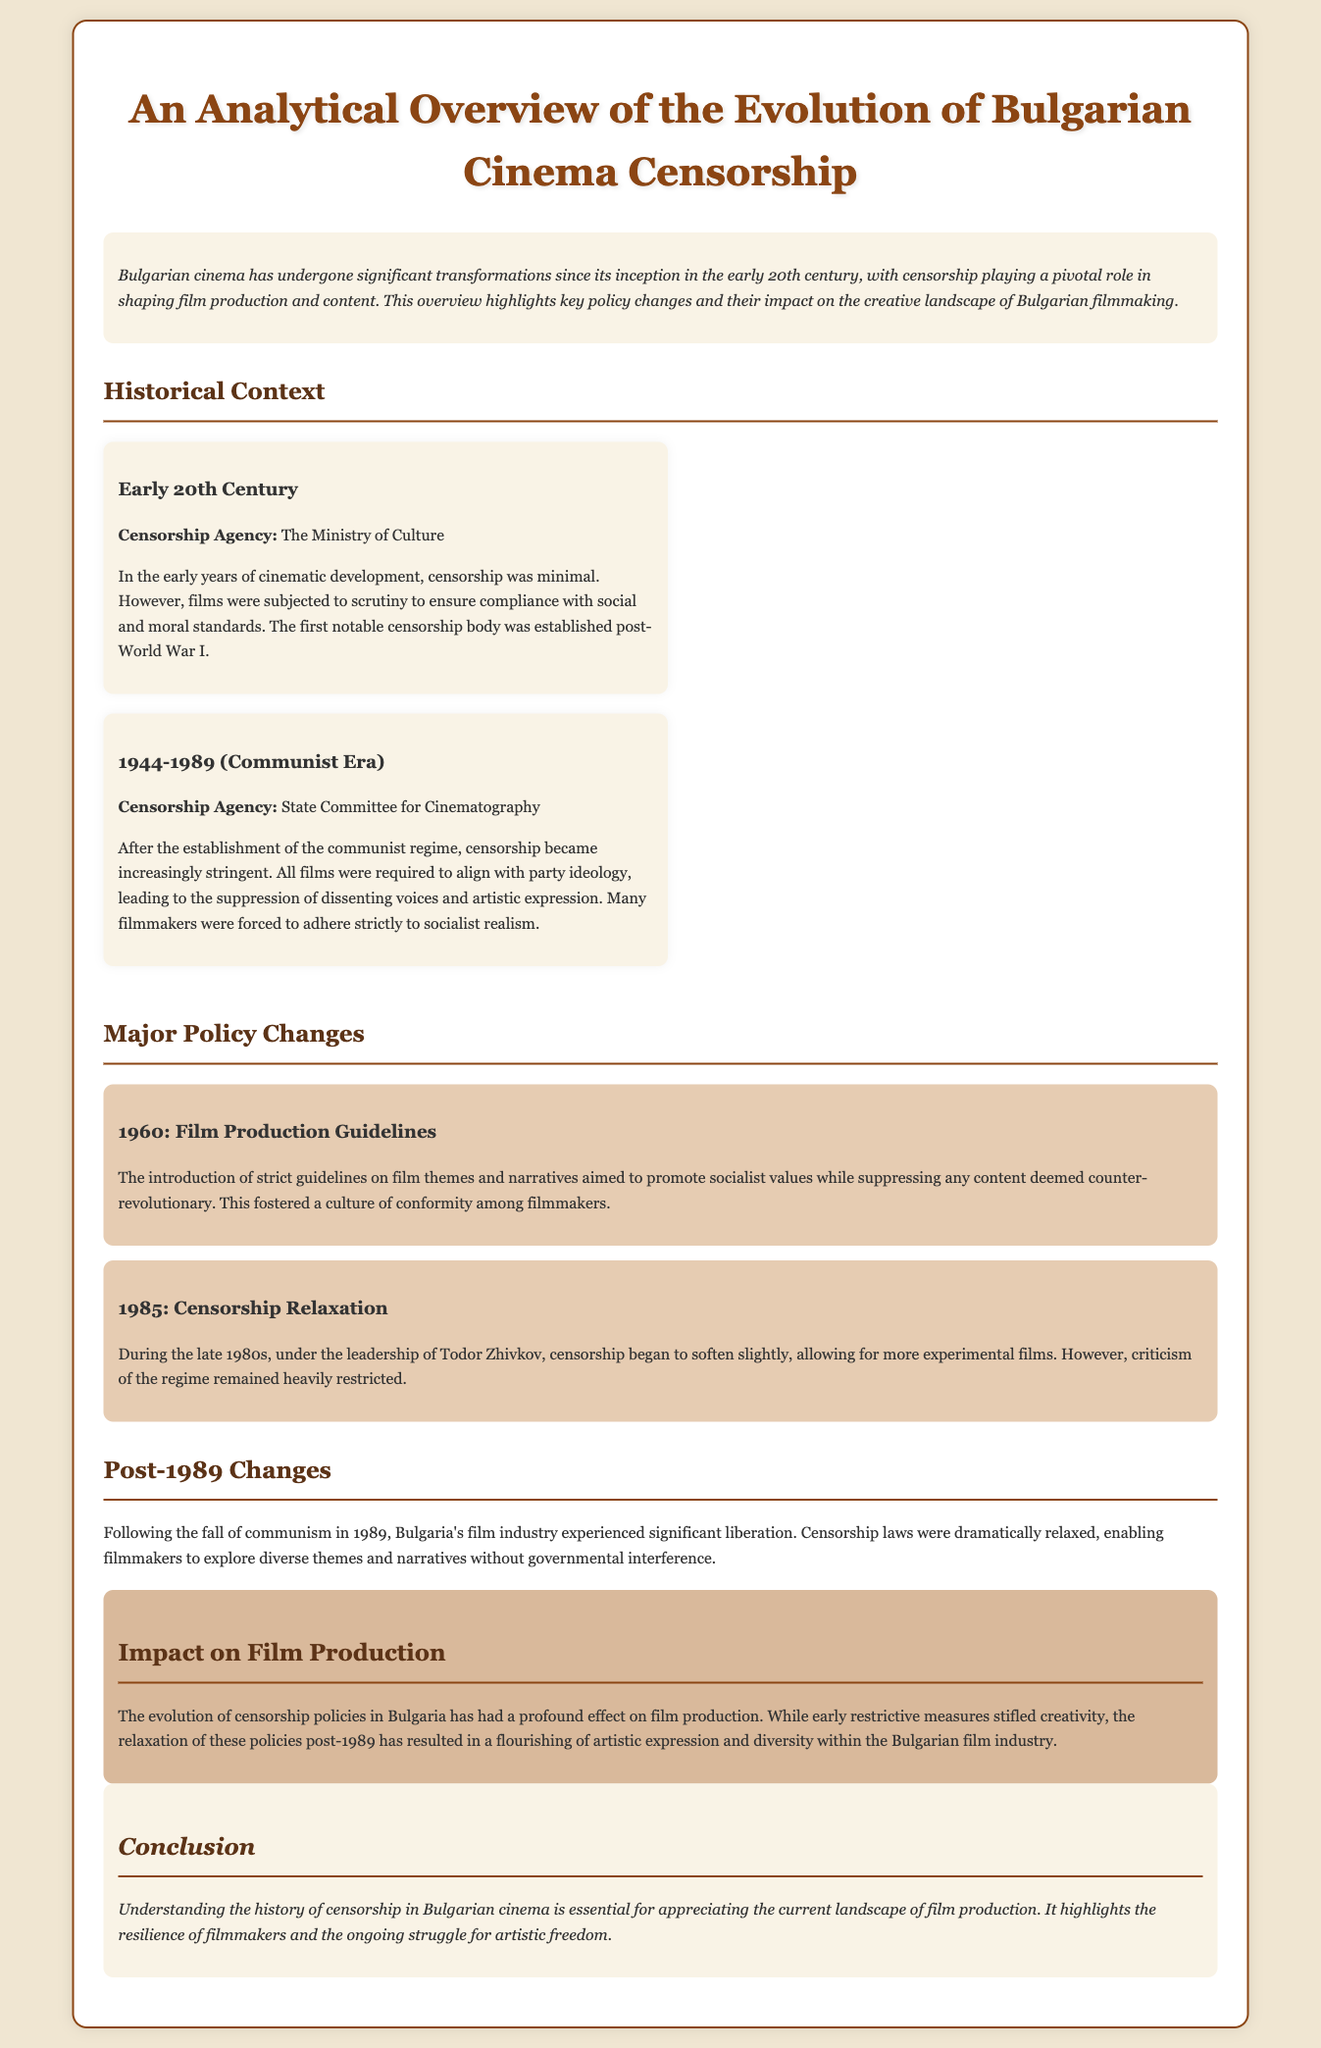What censorship body was established post-World War I? The document states that the first notable censorship body was established post-World War I, which was the Ministry of Culture.
Answer: Ministry of Culture What year did the introduction of strict film production guidelines occur? According to the document, the year when strict film production guidelines were introduced was 1960.
Answer: 1960 What was the impact of censorship policies post-1989? The document states that following the fall of communism in 1989, censorship laws were drastically relaxed, enabling greater creative freedom for filmmakers.
Answer: Creative freedom Which regime's leadership led to a slight relaxation of censorship in 1985? The document mentions that censorship began to soften under the leadership of Todor Zhivkov during the late 1980s.
Answer: Todor Zhivkov What concept dominated film themes during the communist era? The document notes that during the communist era, filmmakers were forced to adhere strictly to socialist realism, which dominated film themes.
Answer: Socialist realism How did early censorship affect creativity in Bulgarian cinema? The document indicates that early restrictive measures stifled creativity, impacting the film production landscape significantly.
Answer: Stifled creativity 